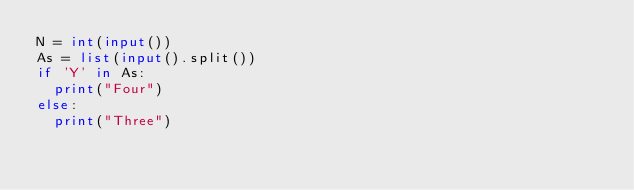Convert code to text. <code><loc_0><loc_0><loc_500><loc_500><_Python_>N = int(input())
As = list(input().split())
if 'Y' in As:
  print("Four")
else:
  print("Three")</code> 